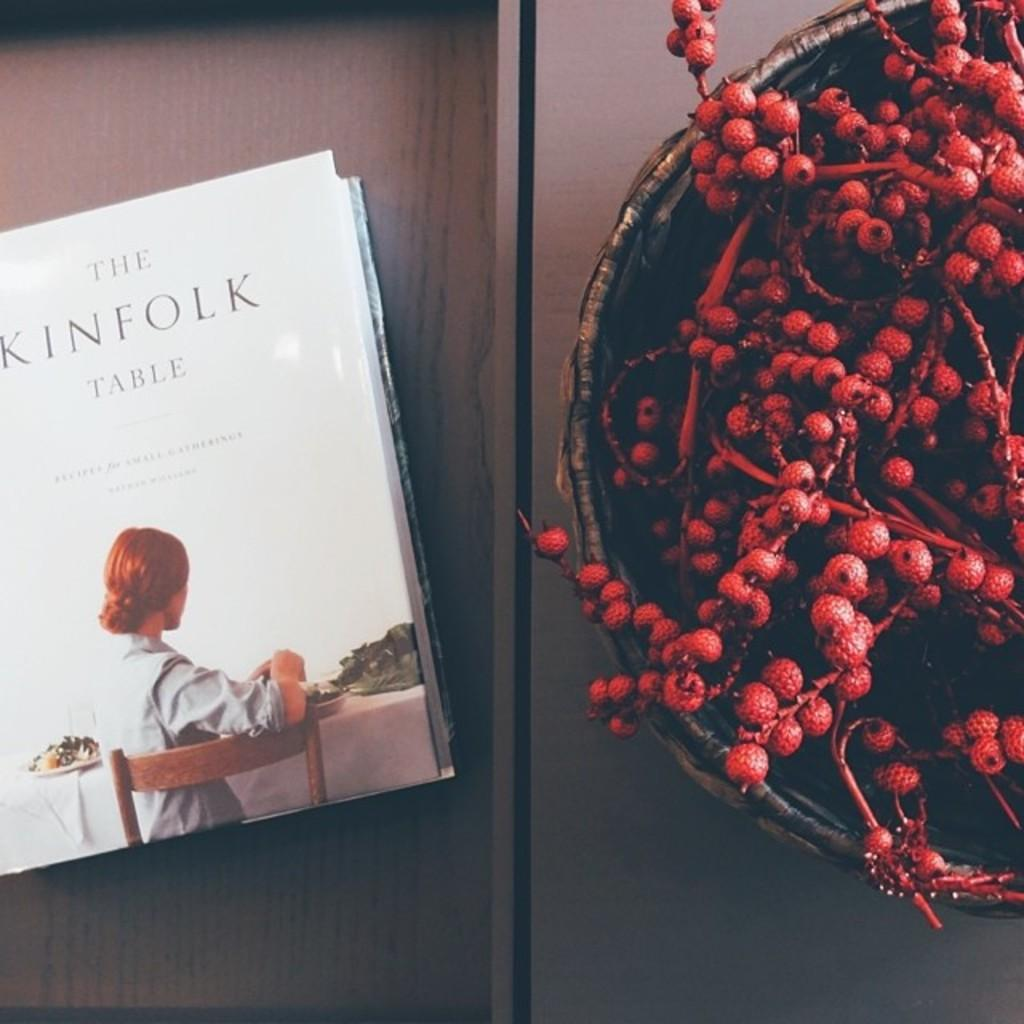<image>
Share a concise interpretation of the image provided. A book entitled "The Kinfolk Table" sits next to a bowl of red berries. 